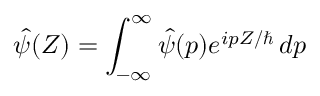Convert formula to latex. <formula><loc_0><loc_0><loc_500><loc_500>\hat { \psi } ( Z ) = \int _ { - \infty } ^ { \infty } \hat { \psi } ( p ) e ^ { i p Z / } \, d p</formula> 